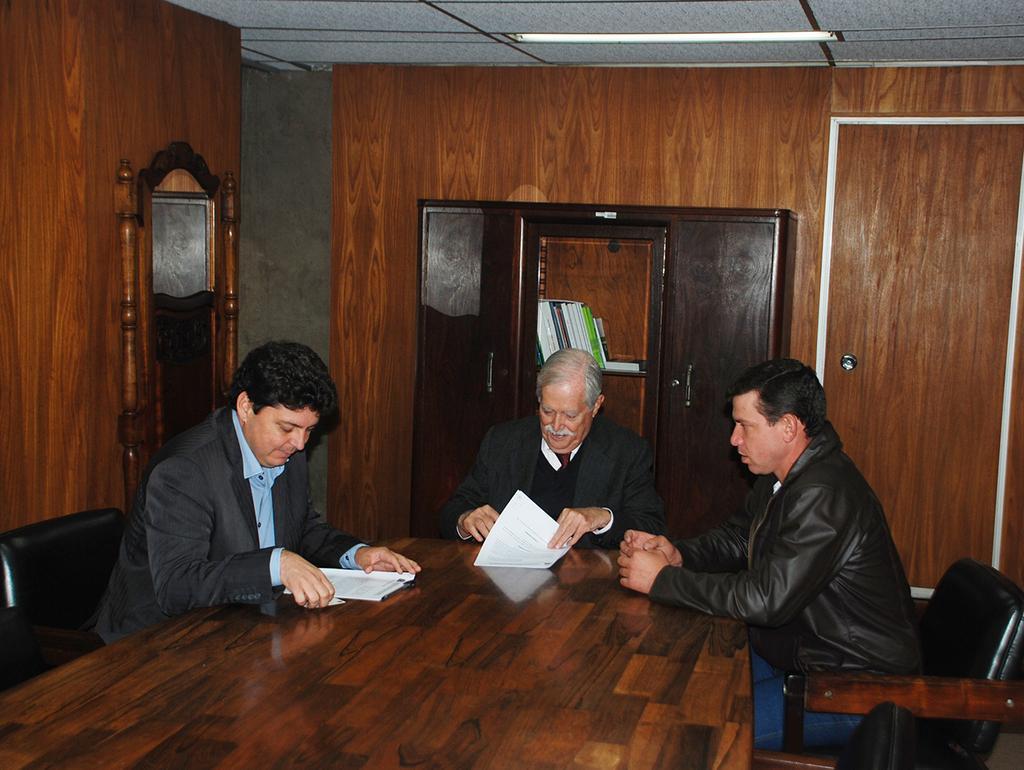Describe this image in one or two sentences. The picture is taken in a room where three people are sitting on the chairs in front of the table and there are papers in there hands, behind the person there is one wooden wardrobe and there are books in them, on the left corner of the picture behind the person there is small mirror and one wooden wall, at the right corner of the picture behind the person there is a wooden door. 